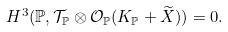<formula> <loc_0><loc_0><loc_500><loc_500>H ^ { 3 } ( \mathbb { P } , \mathcal { T } _ { \mathbb { P } } \otimes \mathcal { O } _ { \mathbb { P } } ( K _ { \mathbb { P } } + \widetilde { X } ) ) = 0 .</formula> 